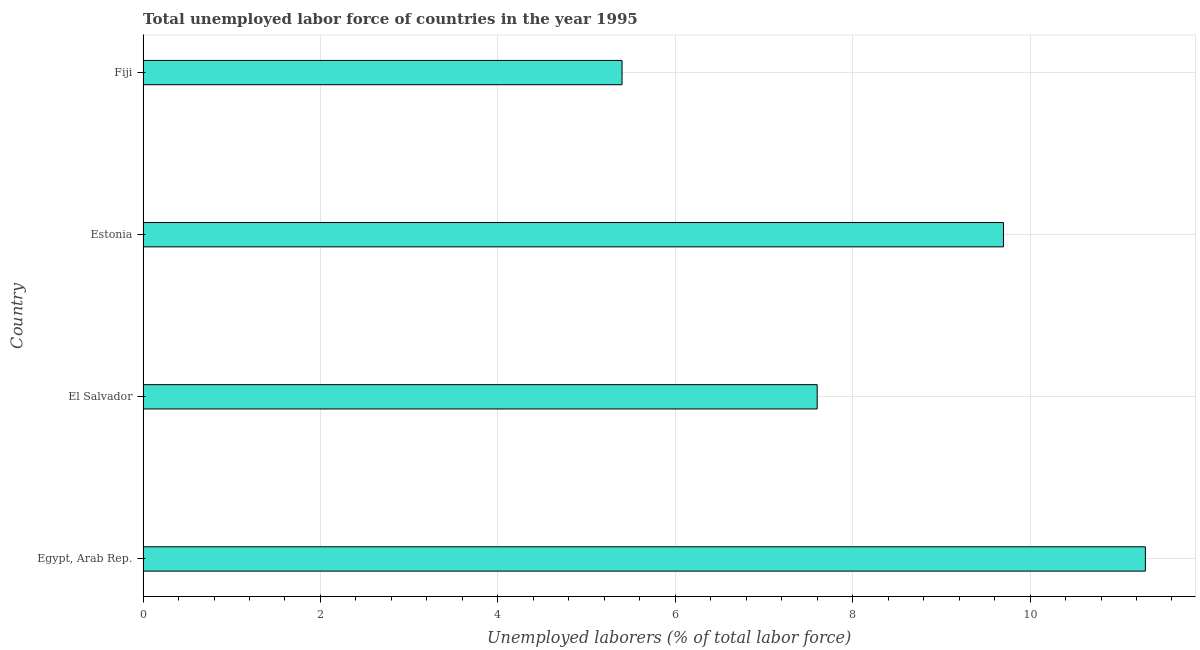Does the graph contain any zero values?
Your answer should be very brief. No. What is the title of the graph?
Your response must be concise. Total unemployed labor force of countries in the year 1995. What is the label or title of the X-axis?
Your answer should be very brief. Unemployed laborers (% of total labor force). What is the label or title of the Y-axis?
Your answer should be compact. Country. What is the total unemployed labour force in Fiji?
Ensure brevity in your answer.  5.4. Across all countries, what is the maximum total unemployed labour force?
Your answer should be very brief. 11.3. Across all countries, what is the minimum total unemployed labour force?
Your answer should be very brief. 5.4. In which country was the total unemployed labour force maximum?
Give a very brief answer. Egypt, Arab Rep. In which country was the total unemployed labour force minimum?
Your answer should be very brief. Fiji. What is the sum of the total unemployed labour force?
Give a very brief answer. 34. What is the average total unemployed labour force per country?
Provide a succinct answer. 8.5. What is the median total unemployed labour force?
Provide a succinct answer. 8.65. In how many countries, is the total unemployed labour force greater than 6 %?
Your answer should be compact. 3. What is the ratio of the total unemployed labour force in El Salvador to that in Estonia?
Keep it short and to the point. 0.78. Is the total unemployed labour force in Egypt, Arab Rep. less than that in El Salvador?
Give a very brief answer. No. Is the difference between the total unemployed labour force in Estonia and Fiji greater than the difference between any two countries?
Your response must be concise. No. What is the difference between the highest and the second highest total unemployed labour force?
Your response must be concise. 1.6. What is the difference between the highest and the lowest total unemployed labour force?
Offer a very short reply. 5.9. In how many countries, is the total unemployed labour force greater than the average total unemployed labour force taken over all countries?
Your answer should be compact. 2. How many bars are there?
Offer a terse response. 4. How many countries are there in the graph?
Provide a succinct answer. 4. What is the difference between two consecutive major ticks on the X-axis?
Ensure brevity in your answer.  2. What is the Unemployed laborers (% of total labor force) in Egypt, Arab Rep.?
Give a very brief answer. 11.3. What is the Unemployed laborers (% of total labor force) in El Salvador?
Provide a succinct answer. 7.6. What is the Unemployed laborers (% of total labor force) in Estonia?
Provide a short and direct response. 9.7. What is the Unemployed laborers (% of total labor force) of Fiji?
Provide a succinct answer. 5.4. What is the difference between the Unemployed laborers (% of total labor force) in Egypt, Arab Rep. and El Salvador?
Your response must be concise. 3.7. What is the difference between the Unemployed laborers (% of total labor force) in Egypt, Arab Rep. and Estonia?
Provide a succinct answer. 1.6. What is the difference between the Unemployed laborers (% of total labor force) in El Salvador and Estonia?
Give a very brief answer. -2.1. What is the difference between the Unemployed laborers (% of total labor force) in El Salvador and Fiji?
Offer a very short reply. 2.2. What is the ratio of the Unemployed laborers (% of total labor force) in Egypt, Arab Rep. to that in El Salvador?
Offer a very short reply. 1.49. What is the ratio of the Unemployed laborers (% of total labor force) in Egypt, Arab Rep. to that in Estonia?
Your answer should be compact. 1.17. What is the ratio of the Unemployed laborers (% of total labor force) in Egypt, Arab Rep. to that in Fiji?
Provide a succinct answer. 2.09. What is the ratio of the Unemployed laborers (% of total labor force) in El Salvador to that in Estonia?
Give a very brief answer. 0.78. What is the ratio of the Unemployed laborers (% of total labor force) in El Salvador to that in Fiji?
Offer a very short reply. 1.41. What is the ratio of the Unemployed laborers (% of total labor force) in Estonia to that in Fiji?
Offer a terse response. 1.8. 